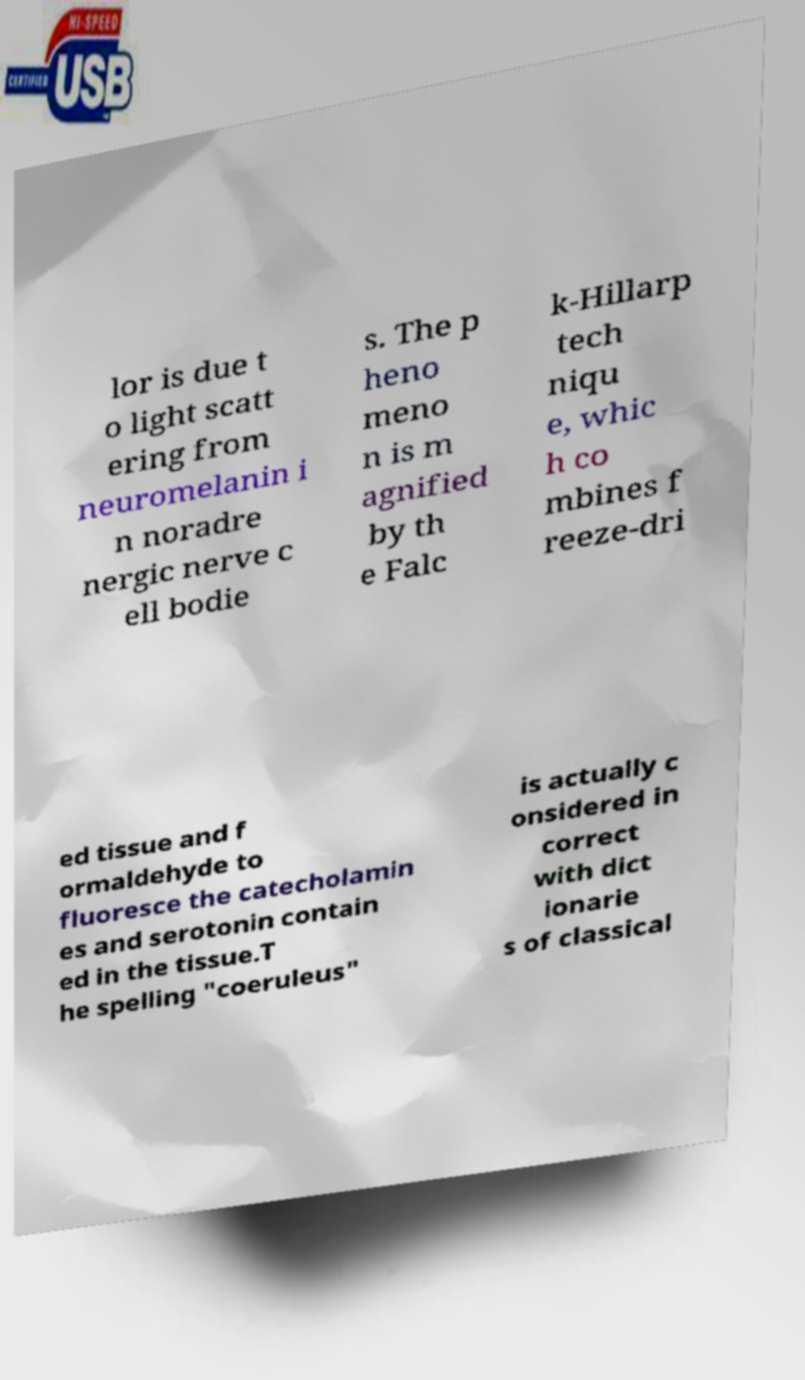Please identify and transcribe the text found in this image. lor is due t o light scatt ering from neuromelanin i n noradre nergic nerve c ell bodie s. The p heno meno n is m agnified by th e Falc k-Hillarp tech niqu e, whic h co mbines f reeze-dri ed tissue and f ormaldehyde to fluoresce the catecholamin es and serotonin contain ed in the tissue.T he spelling "coeruleus" is actually c onsidered in correct with dict ionarie s of classical 